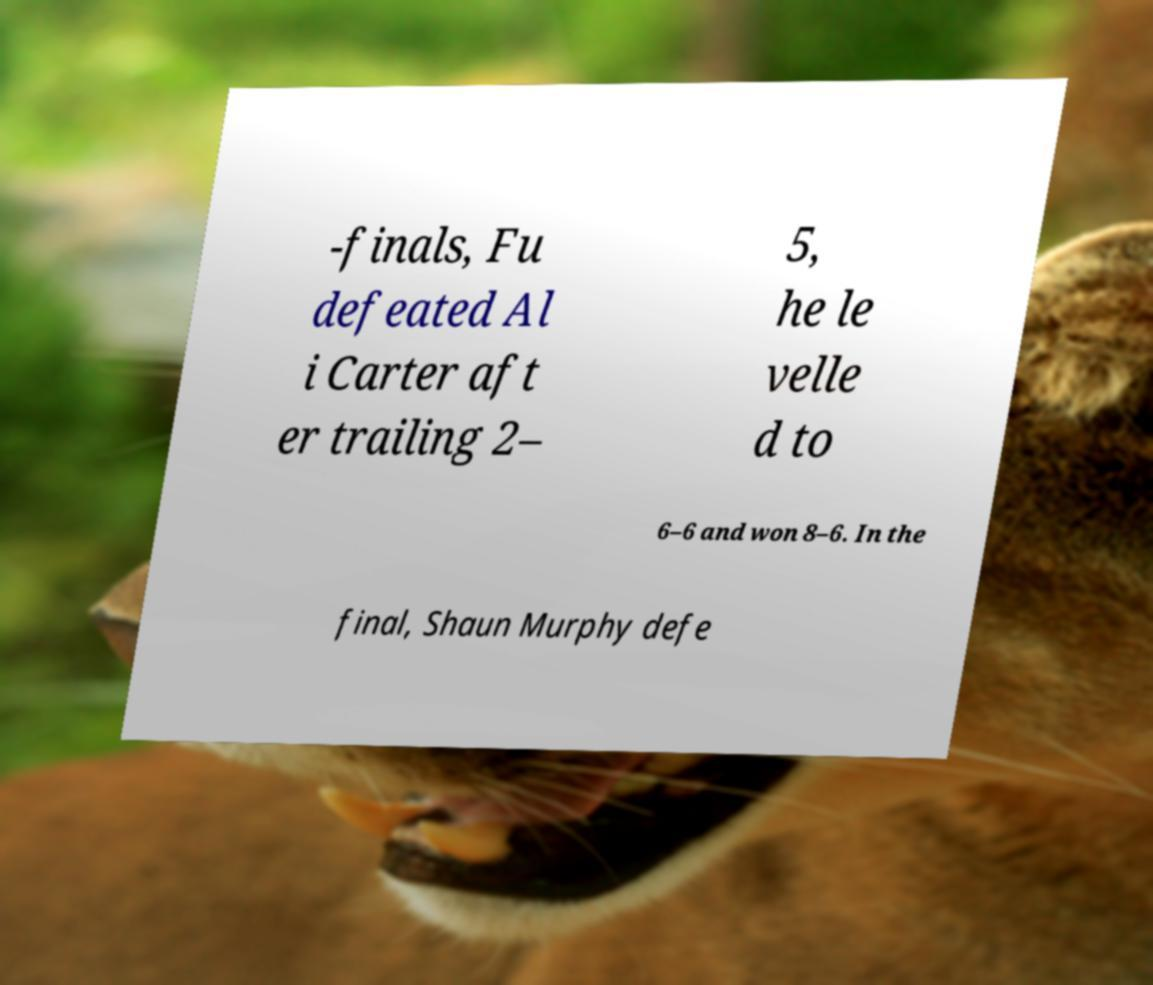Please identify and transcribe the text found in this image. -finals, Fu defeated Al i Carter aft er trailing 2– 5, he le velle d to 6–6 and won 8–6. In the final, Shaun Murphy defe 